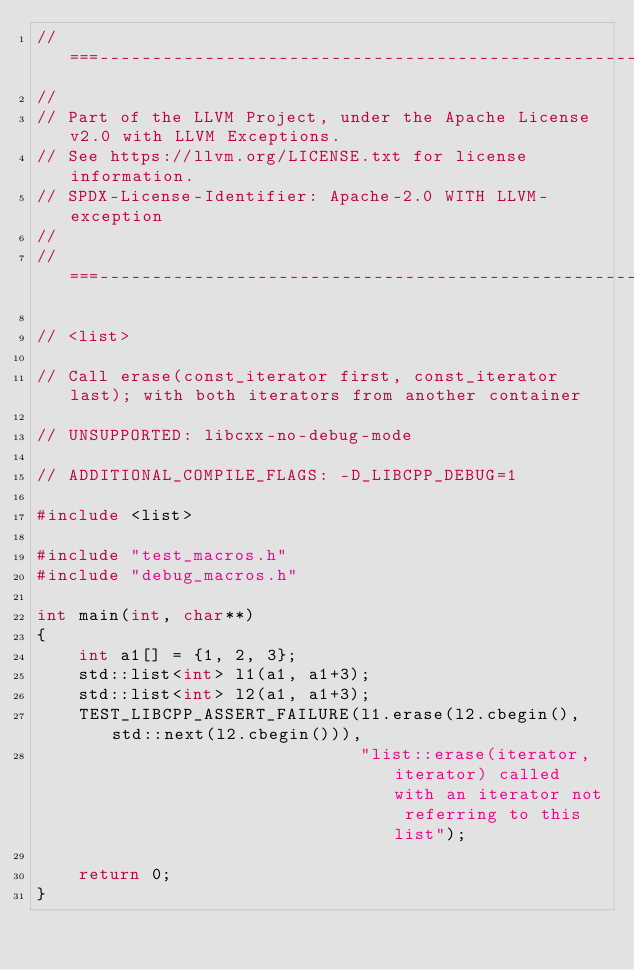Convert code to text. <code><loc_0><loc_0><loc_500><loc_500><_C++_>//===----------------------------------------------------------------------===//
//
// Part of the LLVM Project, under the Apache License v2.0 with LLVM Exceptions.
// See https://llvm.org/LICENSE.txt for license information.
// SPDX-License-Identifier: Apache-2.0 WITH LLVM-exception
//
//===----------------------------------------------------------------------===//

// <list>

// Call erase(const_iterator first, const_iterator last); with both iterators from another container

// UNSUPPORTED: libcxx-no-debug-mode

// ADDITIONAL_COMPILE_FLAGS: -D_LIBCPP_DEBUG=1

#include <list>

#include "test_macros.h"
#include "debug_macros.h"

int main(int, char**)
{
    int a1[] = {1, 2, 3};
    std::list<int> l1(a1, a1+3);
    std::list<int> l2(a1, a1+3);
    TEST_LIBCPP_ASSERT_FAILURE(l1.erase(l2.cbegin(), std::next(l2.cbegin())),
                               "list::erase(iterator, iterator) called with an iterator not referring to this list");

    return 0;
}
</code> 